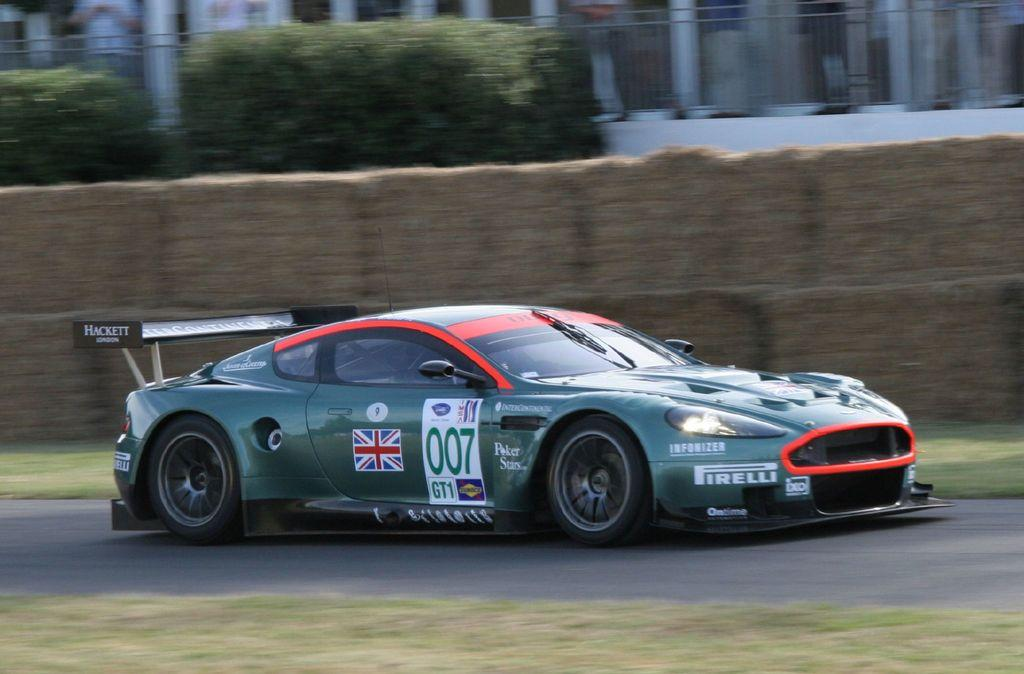What is the main subject in the foreground of the image? There is a sports car in the foreground of the image. What is the sports car doing in the image? The sports car is moving on the road. What can be seen in the background of the image? There is a tiny wall, a planter, a railing, and pillars in the background of the image. How many horses are present in the image? There are no horses present in the image. What type of pets can be seen in the image? There are no pets visible in the image. 